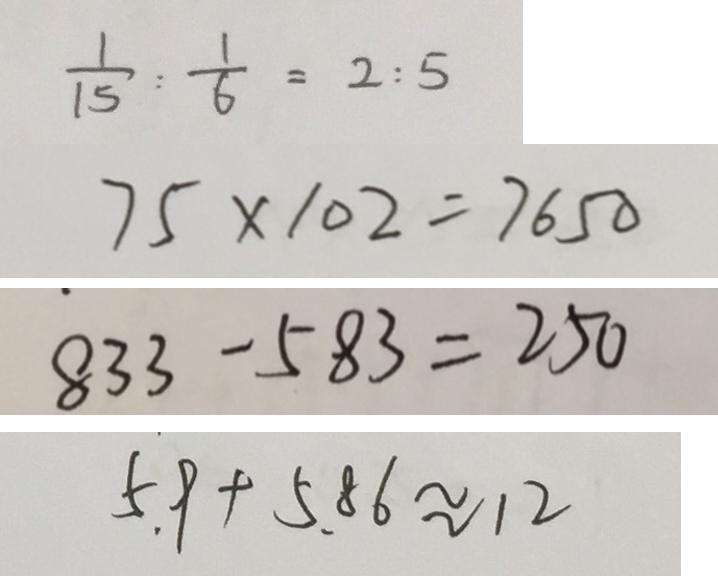Convert formula to latex. <formula><loc_0><loc_0><loc_500><loc_500>\frac { 1 } { 1 5 } : \frac { 1 } { 6 } = 2 : 5 
 7 5 \times 1 0 2 = 7 6 5 0 
 8 3 3 - 5 8 3 = 2 5 0 
 5 . 9 + 5 . 8 6 \approx 1 2</formula> 